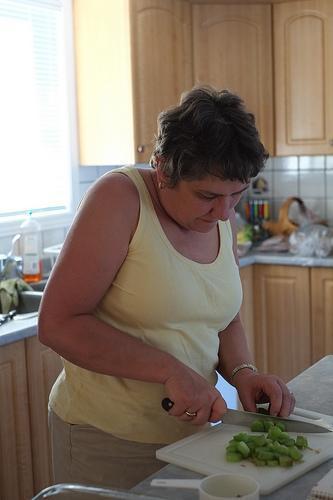How many knives is the woman holding?
Give a very brief answer. 1. How many of the womans arms have a bracelet?
Give a very brief answer. 1. 